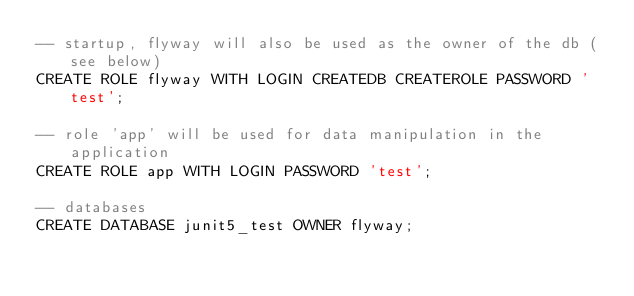Convert code to text. <code><loc_0><loc_0><loc_500><loc_500><_SQL_>-- startup, flyway will also be used as the owner of the db (see below)
CREATE ROLE flyway WITH LOGIN CREATEDB CREATEROLE PASSWORD 'test';

-- role 'app' will be used for data manipulation in the application
CREATE ROLE app WITH LOGIN PASSWORD 'test';

-- databases
CREATE DATABASE junit5_test OWNER flyway;</code> 